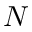Convert formula to latex. <formula><loc_0><loc_0><loc_500><loc_500>N</formula> 